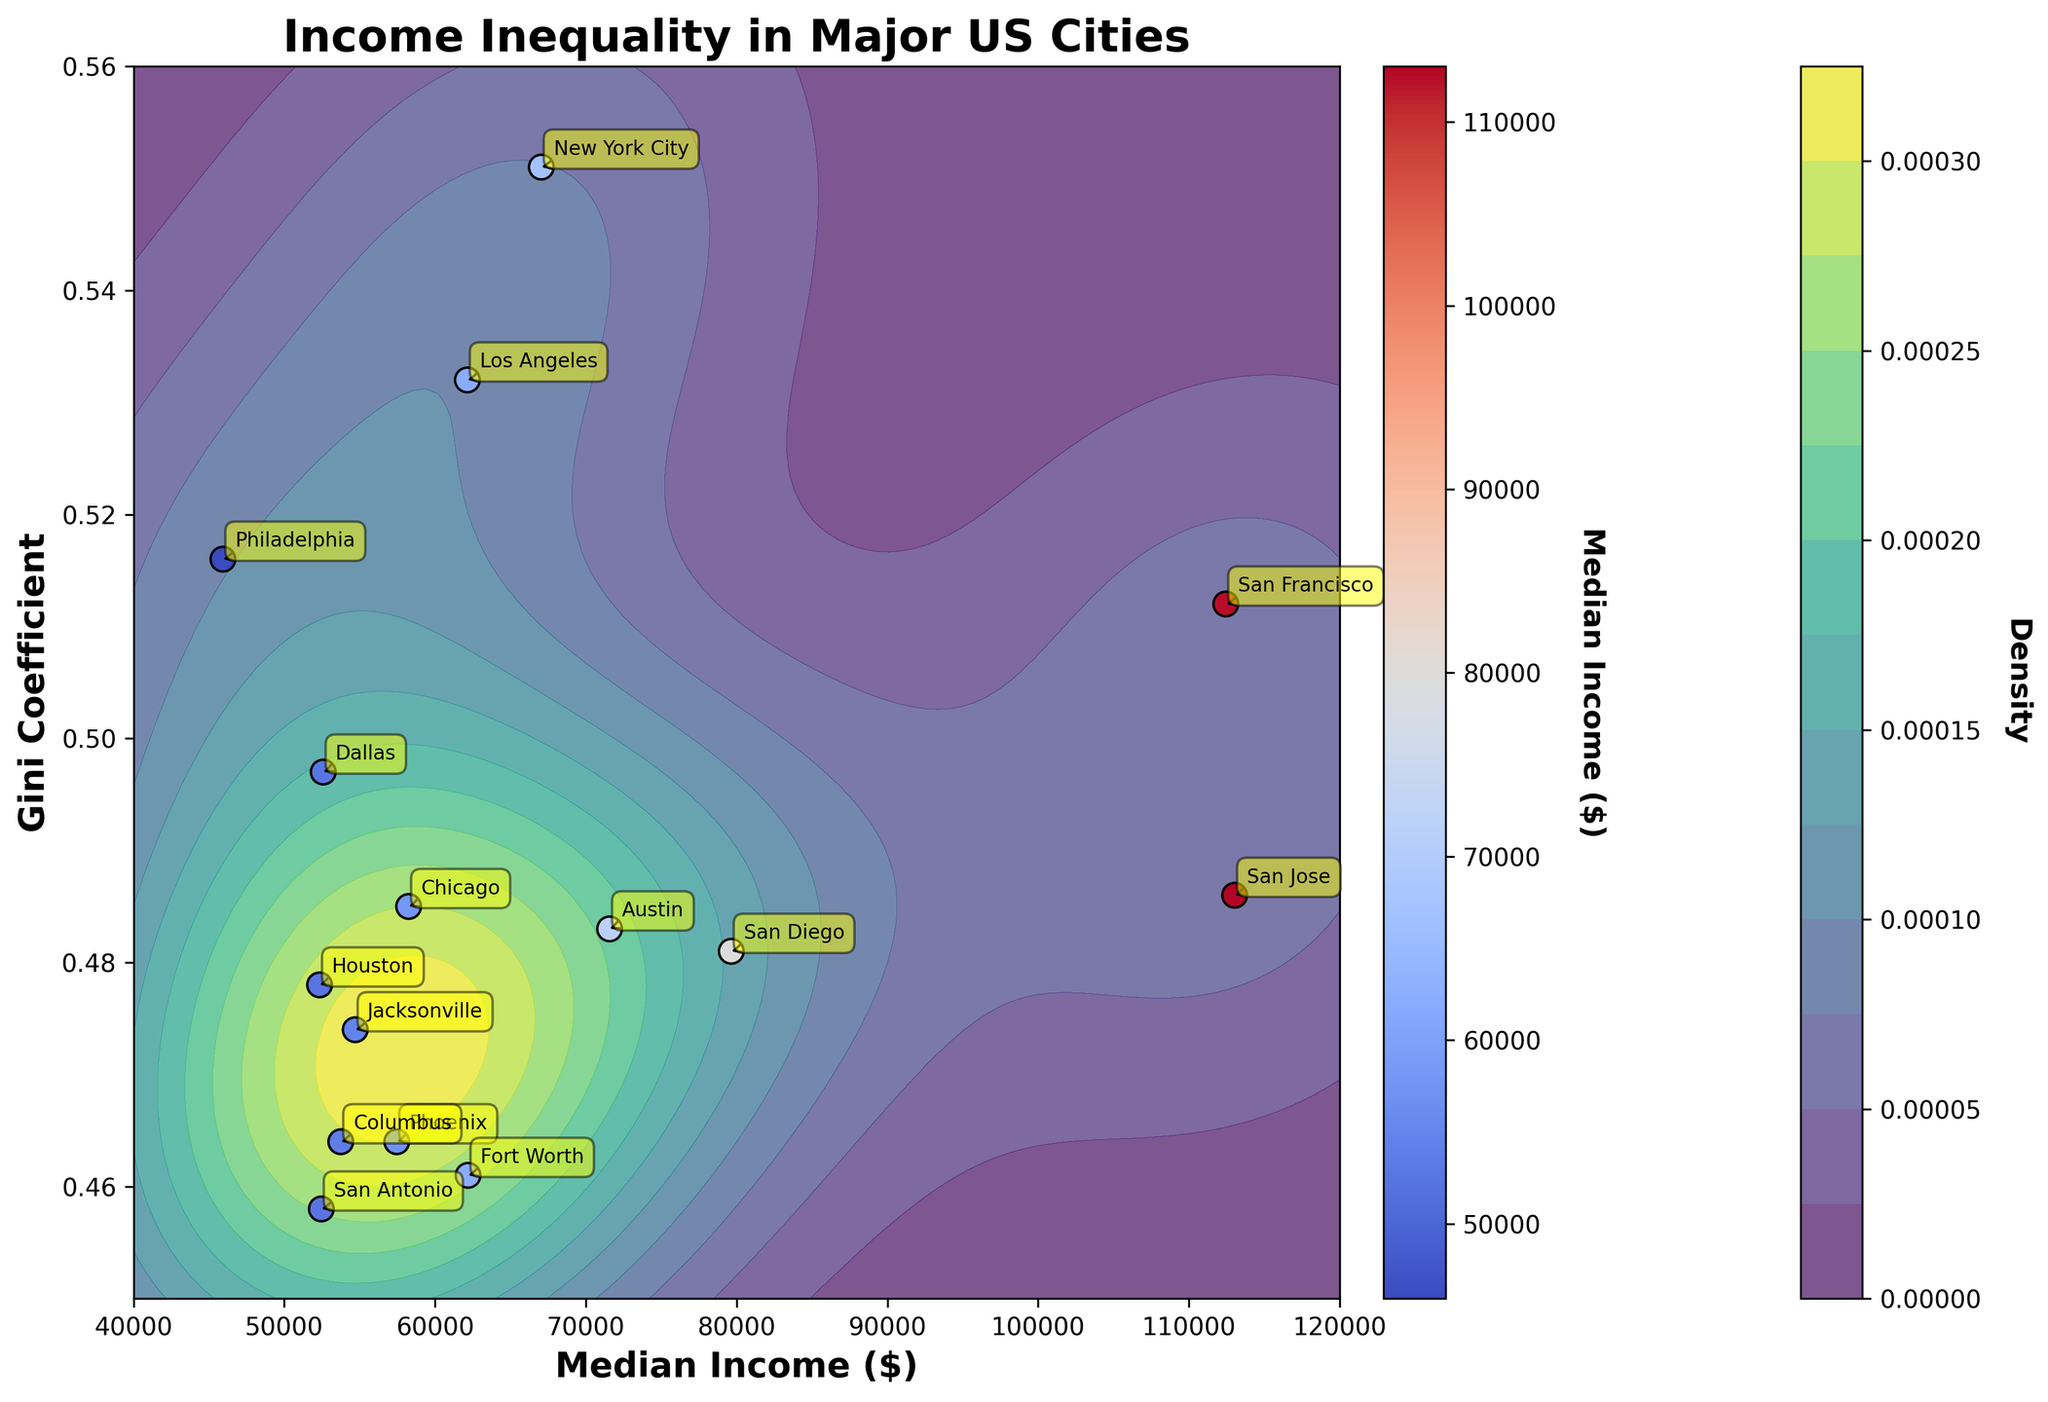What is the title of the figure? The title is always located at the top of the figure and is typically in a larger font size.
Answer: Income Inequality in Major US Cities How many major US cities are plotted in the figure? By counting the annotated labels for each city on the scatter plot, we can find the number of cities.
Answer: 15 What is the median income of San Francisco? Locate San Francisco's label on the scatter plot, then refer to the x-axis position of the corresponding dot.
Answer: $112,449 Which city has the highest Gini Coefficient? Based on the y-axis, find the point furthest up on the graph, then check the annotation.
Answer: New York City How does the Gini Coefficient of Philadelphia compare to the median Gini Coefficient in the plot? First, locate Philadelphia's Gini Coefficient on the scatter plot. Then visually estimate the median of all Gini Coefficients, which is around the middle value of the y-axis range.
Answer: Slightly higher Which city has the highest median income and what is its Gini Coefficient? Locate the city with the furthest right position on the x-axis, then check both annotations for city and Gini Coefficient.
Answer: San Jose, 0.486 Is the density higher in regions with high median income or low median income? Look at the contour lines and color indications; darker regions represent higher density. Compare dark regions at both extremes of the median income on the x-axis.
Answer: Higher in regions with low median income What is the relationship between median income and Gini Coefficient among the plotted cities? Look at the overall trend of the scatter plot if points with higher median income tend to cluster around certain Gini Coefficients.
Answer: No clear relationship; they are scattered Which two cities have the closest Gini Coefficients, and what are their values? By closely inspecting the scatter plot, identify two points that are closest vertically and check their annotations.
Answer: Houston (0.478) and San Diego (0.481) What does the color of each scatter point represent in the plot? By reading the color bar explanation next to the scatter plot, identify what it describes.
Answer: Median Income 